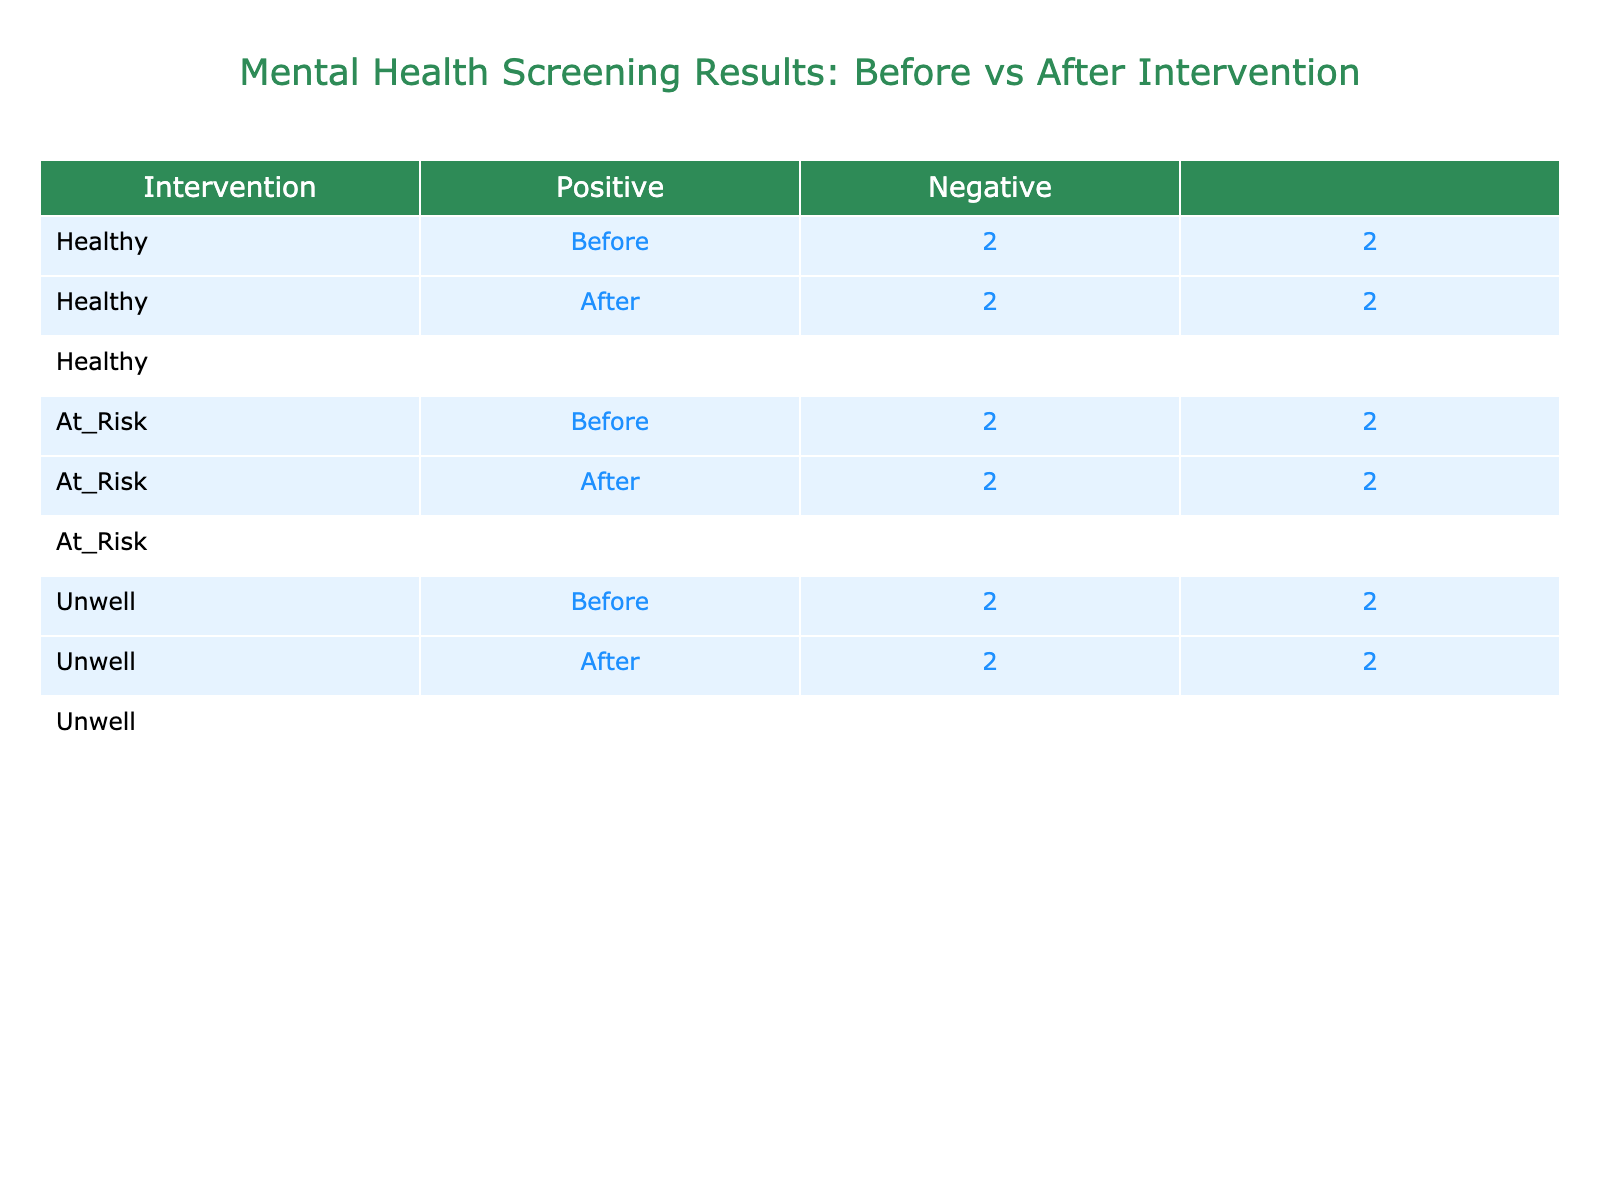What is the total number of people categorized as 'Unwell' before the intervention? Referring to the 'Before' column for the 'Unwell' category, we see there are 3 individuals (Positive: 1, Negative: 2). Thus, when combined, the total is 3.
Answer: 3 What is the difference in the number of 'Healthy' predictions before and after the intervention? In the 'Healthy' category, there are 2 (Positive: 1, Negative: 1) predictions before the intervention and 1 (Negative: 1) after the intervention. The difference is 2 - 1 = 1.
Answer: 1 Is it true that the number of 'At Risk' individuals accurately predicted as 'Negative' increased after the intervention? In the 'At Risk' category, there are 1 individual predicted as 'Negative' before the intervention and 2 after the intervention. Since the number increased, the statement is true.
Answer: Yes What is the total number of people categorized as 'At Risk' who were predicted as 'Positive' after the intervention? In the 'At Risk' category after the intervention, there are 1 person predicted as 'Positive' (Positive: 1) and 1 person predicted as 'Negative'. Therefore, the total predicted as 'Positive' is 1.
Answer: 1 How many predictions were made in total for each group (Healthy, At Risk, Unwell) before and after the intervention? Before the intervention, there are 2 (Healthy) + 3 (At Risk) + 3 (Unwell) = 8 predictions in total. After the intervention, there are 1 (Healthy) + 2 (At Risk) + 2 (Unwell) = 5 predictions in total. Thus, the totals are 8 before and 5 after.
Answer: 8 before, 5 after What percentage of 'Unwell' individuals were correctly predicted before the intervention? In the 'Unwell' category before the intervention, there are 1 correct (Positive) prediction out of a total of 3 predictions. Thus, the percentage is (1/3)*100 = 33.33%.
Answer: 33.33% What is the total number of individuals flagged as 'Negative' after the intervention? Checking the totals for 'Negative' predictions in the 'After' category: 'Healthy' has 1, 'At Risk' has 1, and 'Unwell' has 2. Summing these gives 1 + 1 + 2 = 4.
Answer: 4 Did the community support interventions reduce the number of individuals categorized as 'At Risk' from before to after? Before the intervention, there were 3 individuals categorized as 'At Risk' (2 positive, 1 negative). After the intervention, there are 2 individuals categorized as 'At Risk' (1 positive, 1 negative). The number decreased from 3 to 2, indicating a reduction.
Answer: Yes 